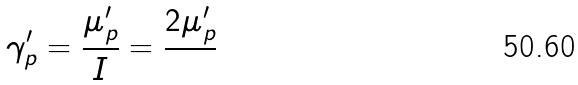Convert formula to latex. <formula><loc_0><loc_0><loc_500><loc_500>\gamma _ { p } ^ { \prime } = \frac { \mu _ { p } ^ { \prime } } { I } = \frac { 2 \mu _ { p } ^ { \prime } } { }</formula> 